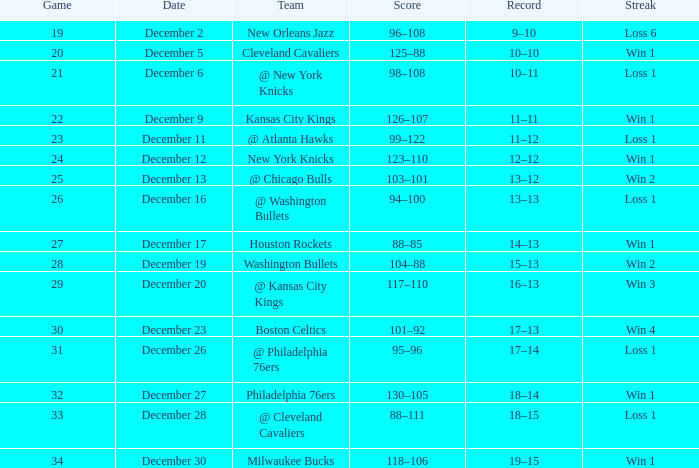What is the Streak on December 30? Win 1. 